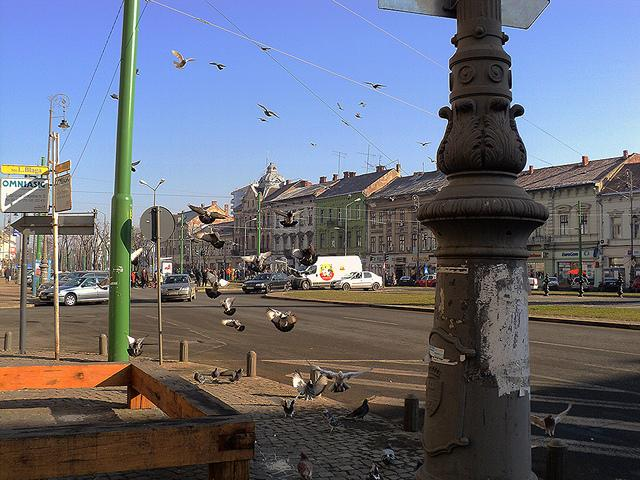Those birds are related to what other type of bird? Please explain your reasoning. dove. The birds are doves. 